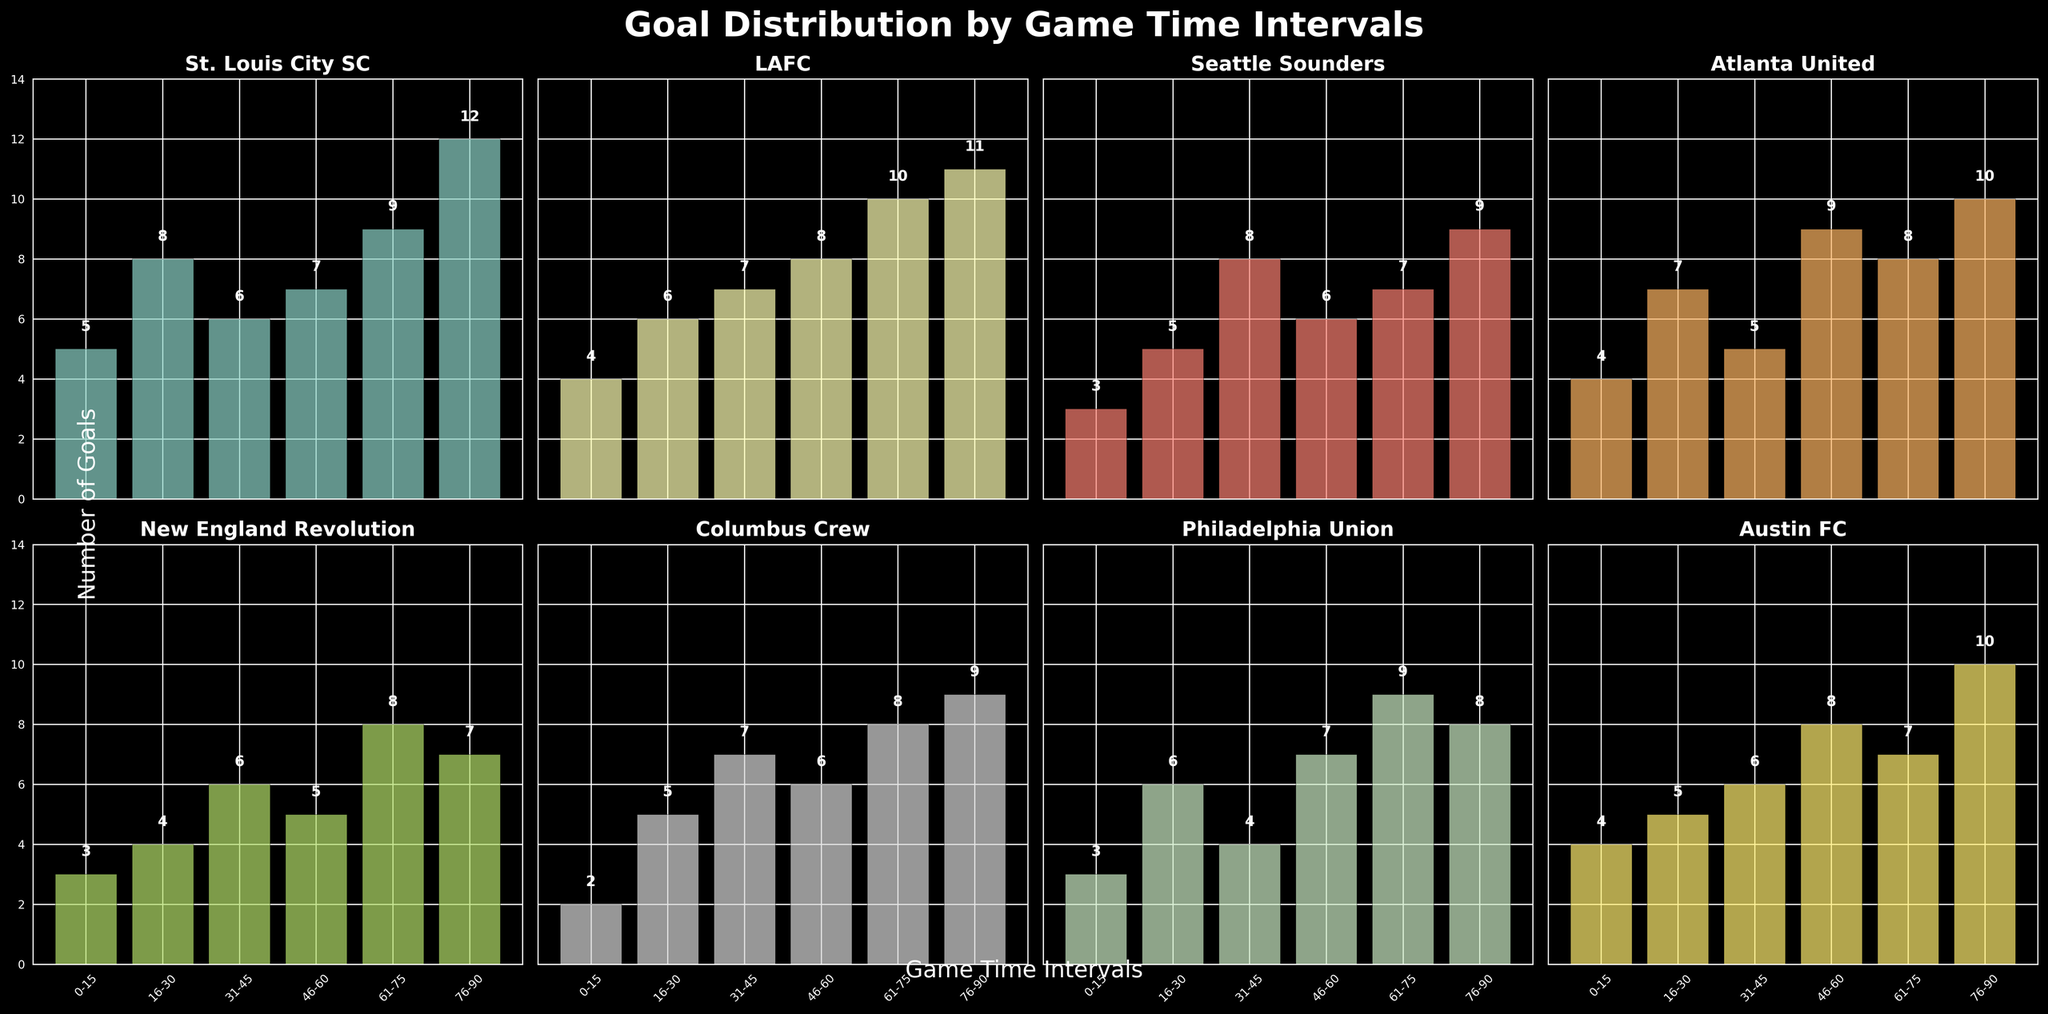Which team scored the most goals in the 76-90 minute interval? Look at each subplot and identify the goals for the 76-90 minute interval. St. Louis City SC scored 12, LAFC scored 11, Seattle Sounders scored 9, Atlanta United scored 10, New England Revolution scored 7, Columbus Crew scored 9, Philadelphia Union scored 8, and Austin FC scored 10. St. Louis City SC has the highest number with 12 goals.
Answer: St. Louis City SC How many total goals did St. Louis City SC score across all intervals? Add the goals from all intervals for St. Louis City SC: 5 + 8 + 6 + 7 + 9 + 12. This equals 47 goals.
Answer: 47 Which team has the lowest number of goals in the 31-45 minute interval? Look at the number of goals in the 31-45 minute interval for each team. St. Louis City SC has 6, LAFC has 7, Seattle Sounders have 8, Atlanta United have 5, New England Revolution has 6, Columbus Crew has 7, Philadelphia Union has 4, and Austin FC has 6. Philadelphia Union has the lowest number with 4 goals.
Answer: Philadelphia Union Which team shows the most balanced goal distribution across all time intervals? Observe the variation of goals scored across each interval. A lower range between the highest and lowest goals indicates a more balanced distribution. LAFC scores 4, 6, 7, 8, 10, and 11 respectively, which shows a steady increase without wide fluctuations.
Answer: LAFC Compare the total number of goals scored by St. Louis City SC and Seattle Sounders. Which team has more? Calculate the total goals for each team. St. Louis City SC: 5 + 8 + 6 + 7 + 9 + 12 = 47. Seattle Sounders: 3 + 5 + 8 + 6 + 7 + 9 = 38. St. Louis City SC has more goals.
Answer: St. Louis City SC Which interval has the highest combined total goals scored among all teams? Calculate the sum of goals scored by all teams in each interval: 
- 0-15: 5+4+3+4+3+2+3+4 = 28
- 16-30: 8+6+5+7+4+5+6+5 = 46
- 31-45: 6+7+8+5+6+7+4+6 = 49
- 46-60: 7+8+6+9+5+6+7+8 = 56
- 61-75: 9+10+7+8+8+8+9+7 = 66
- 76-90: 12+11+9+10+7+9+8+10 = 76
The 76-90 minute interval has the highest combined total with 76 goals.
Answer: 76-90 What is the difference in goals scored between the first and last intervals for St. Louis City SC? Subtract the number of goals scored in the 0-15 interval from the number in the 76-90 interval for St. Louis City SC: 12 - 5 = 7 goals.
Answer: 7 Which team scored more goals in the 46-60 minute interval, Atlanta United or Philadelphia Union? Compare the number of goals in the 46-60 minute interval: Atlanta United scored 9 goals, and Philadelphia Union scored 7 goals. Atlanta United scored more.
Answer: Atlanta United 